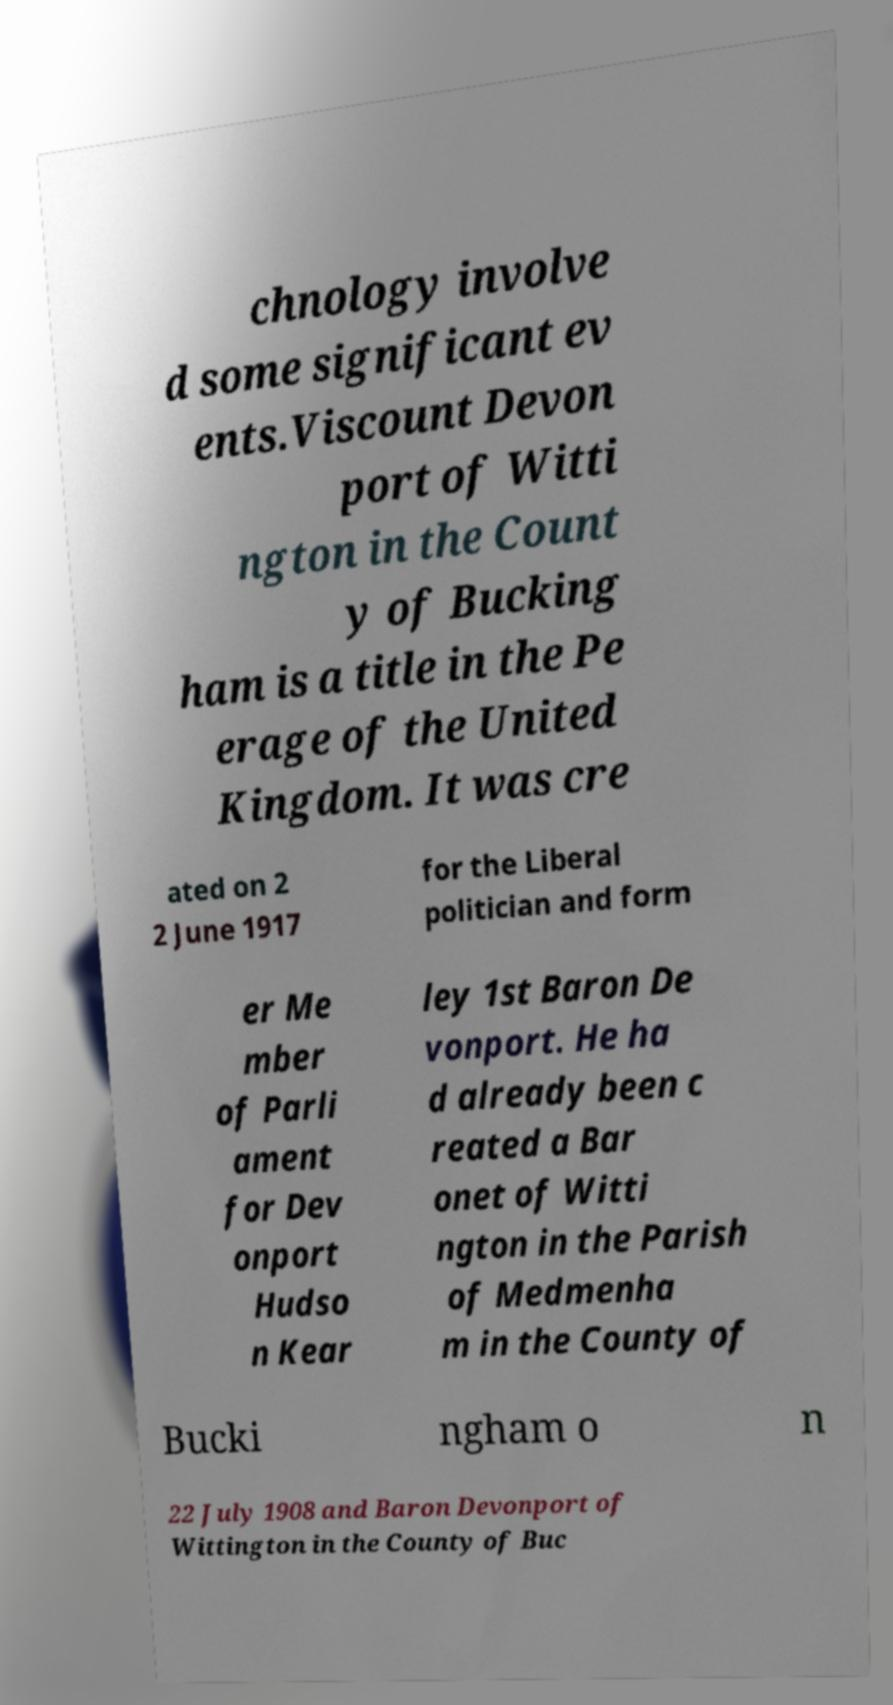What messages or text are displayed in this image? I need them in a readable, typed format. chnology involve d some significant ev ents.Viscount Devon port of Witti ngton in the Count y of Bucking ham is a title in the Pe erage of the United Kingdom. It was cre ated on 2 2 June 1917 for the Liberal politician and form er Me mber of Parli ament for Dev onport Hudso n Kear ley 1st Baron De vonport. He ha d already been c reated a Bar onet of Witti ngton in the Parish of Medmenha m in the County of Bucki ngham o n 22 July 1908 and Baron Devonport of Wittington in the County of Buc 